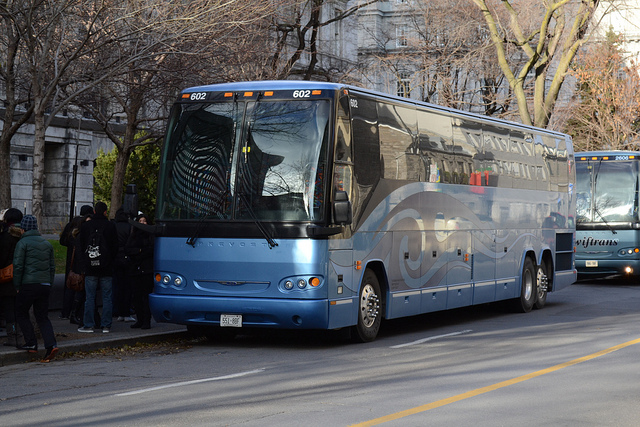What might be the capacity of this bus? A typical coach bus like the one in the image can carry between 50 to 60 passengers, considering the size and the general number of seats such buses are equipped with. 